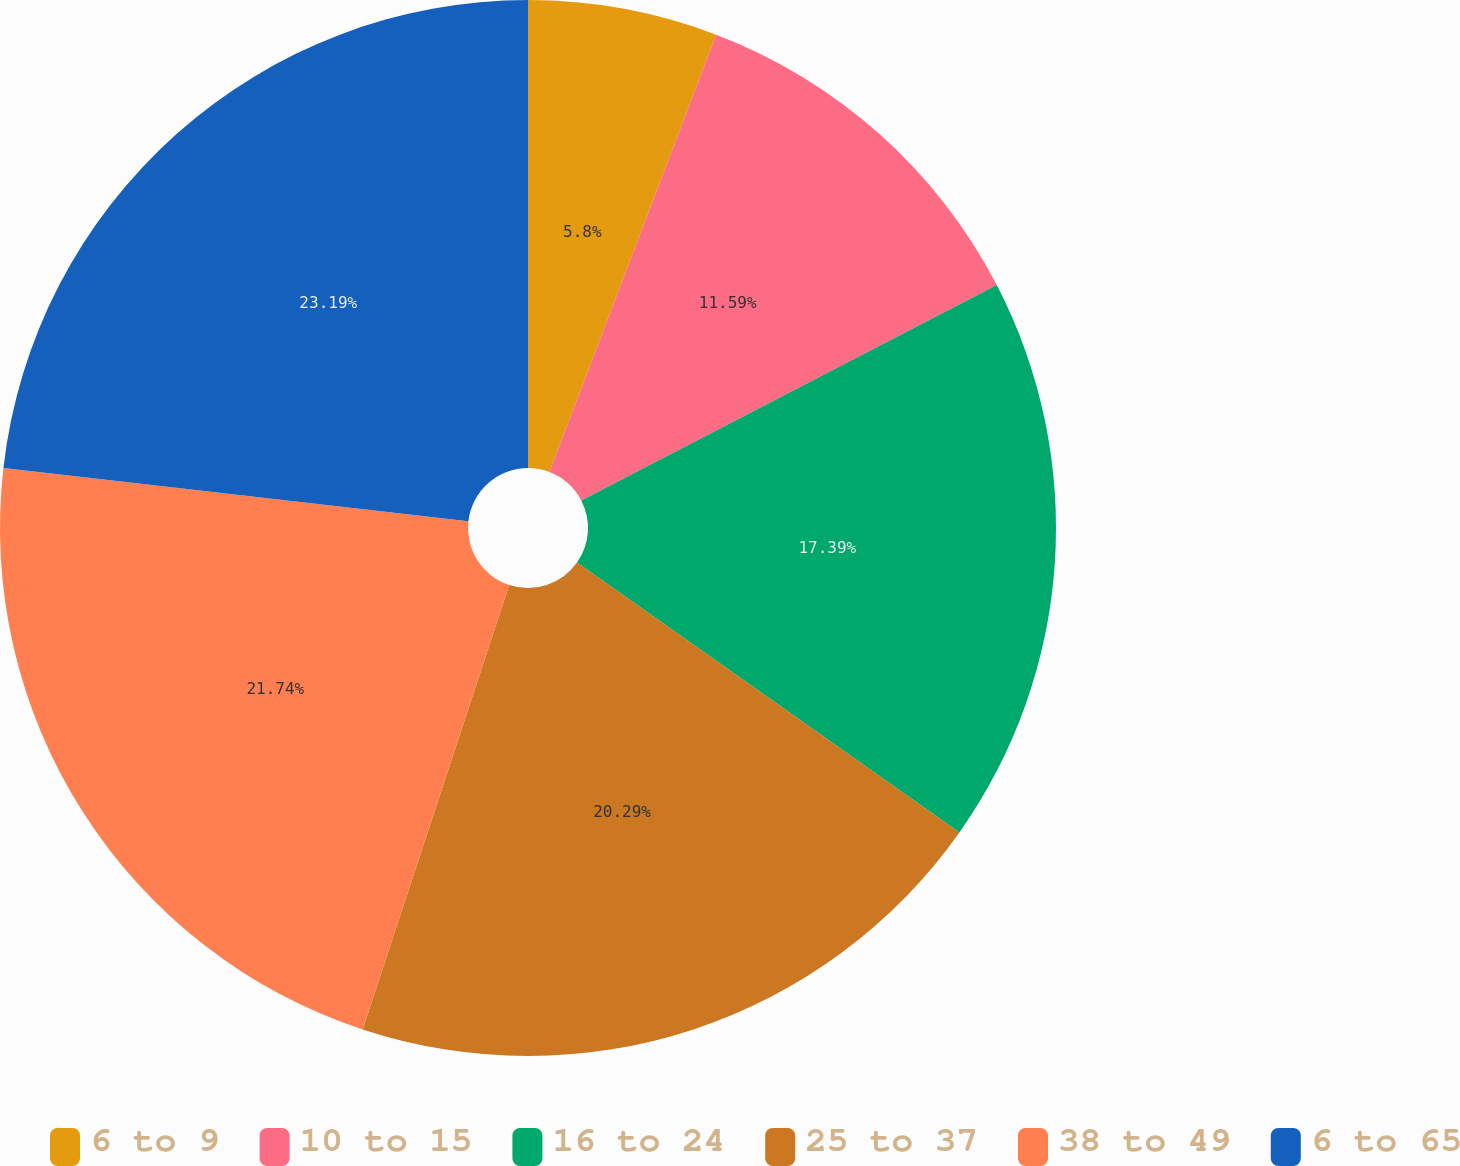<chart> <loc_0><loc_0><loc_500><loc_500><pie_chart><fcel>6 to 9<fcel>10 to 15<fcel>16 to 24<fcel>25 to 37<fcel>38 to 49<fcel>6 to 65<nl><fcel>5.8%<fcel>11.59%<fcel>17.39%<fcel>20.29%<fcel>21.74%<fcel>23.19%<nl></chart> 